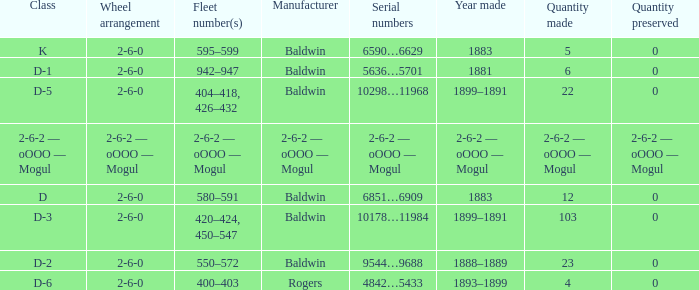What is the wheel arrangement when the year made is 1881? 2-6-0. 